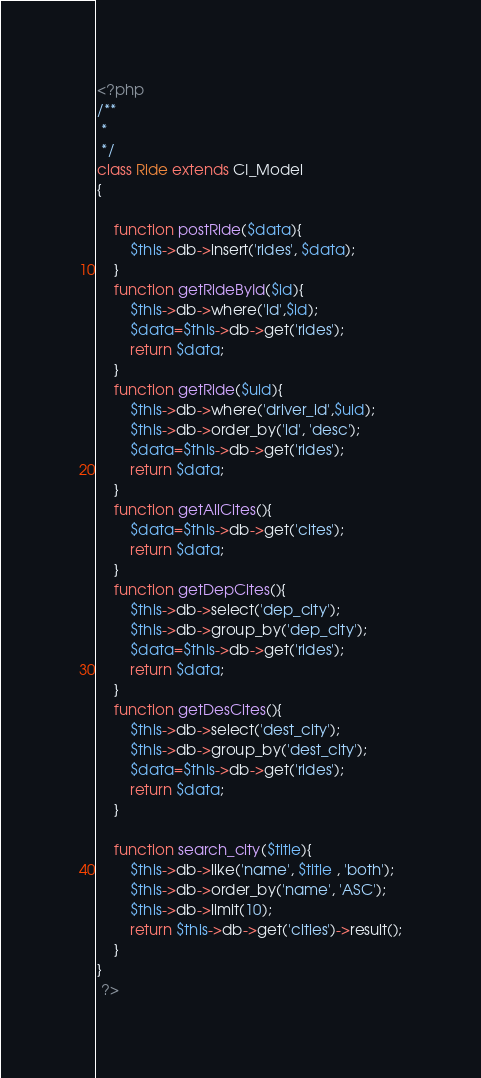<code> <loc_0><loc_0><loc_500><loc_500><_PHP_><?php 
/**
 * 
 */
class Ride extends CI_Model
{

	function postRide($data){
		$this->db->insert('rides', $data);
	}
    function getRideById($id){
        $this->db->where('id',$id);
        $data=$this->db->get('rides');
        return $data;
    }
	function getRide($uid){
		$this->db->where('driver_id',$uid);
        $this->db->order_by('id', 'desc');
		$data=$this->db->get('rides');
		return $data;
	}
    function getAllCites(){
        $data=$this->db->get('cites');
        return $data;
    }
    function getDepCites(){
        $this->db->select('dep_city');
        $this->db->group_by('dep_city');
        $data=$this->db->get('rides');
        return $data;
    }
    function getDesCites(){
        $this->db->select('dest_city');
        $this->db->group_by('dest_city');
        $data=$this->db->get('rides');
        return $data;
    }

    function search_city($title){
        $this->db->like('name', $title , 'both');
        $this->db->order_by('name', 'ASC');
        $this->db->limit(10);
        return $this->db->get('cities')->result();
    }
}
 ?></code> 